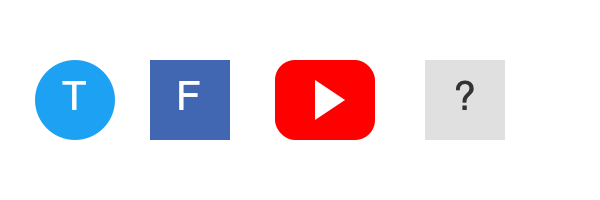Based on the visual sequence of social media platform icons and their potential impact on free speech, which platform should logically come next? To determine the next platform in the sequence, we need to analyze the trend:

1. Twitter (T): Known for its open, real-time communication. Often associated with breaking news and rapid information spread.

2. Facebook (F): More controlled environment with stricter content policies. Has been criticized for content moderation practices affecting free speech.

3. YouTube: Video platform with increasing content restrictions and demonetization policies, impacting creators' freedom of expression.

4. The missing platform should continue this trend of increasing content control and potential limitations on free speech.

Considering the progression, the next logical platform would be one with even stricter content policies or government oversight. TikTok fits this description due to:

a) Its ownership by ByteDance, a Chinese company subject to strict government regulations.
b) Concerns about data privacy and potential censorship.
c) Algorithmic content control that may limit the spread of certain types of information.

TikTok represents a further step in the direction of increased content control and potential limitations on free expression, aligning with the sequence's progression.
Answer: TikTok 